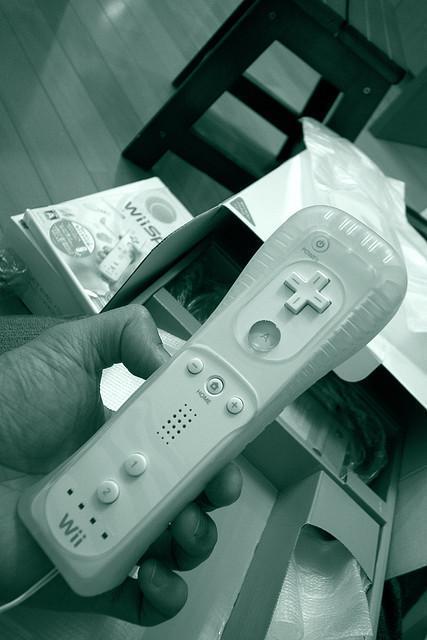How many books are visible?
Give a very brief answer. 2. How many people can you see?
Give a very brief answer. 1. How many buses are behind a street sign?
Give a very brief answer. 0. 